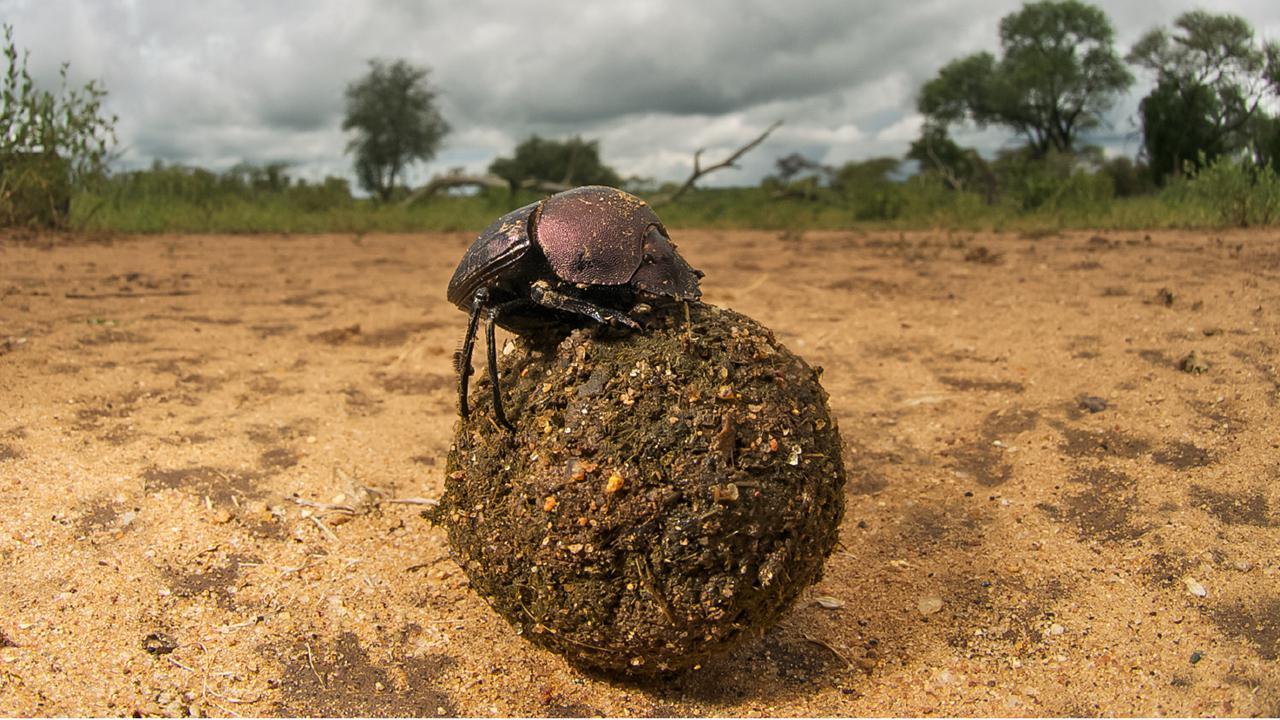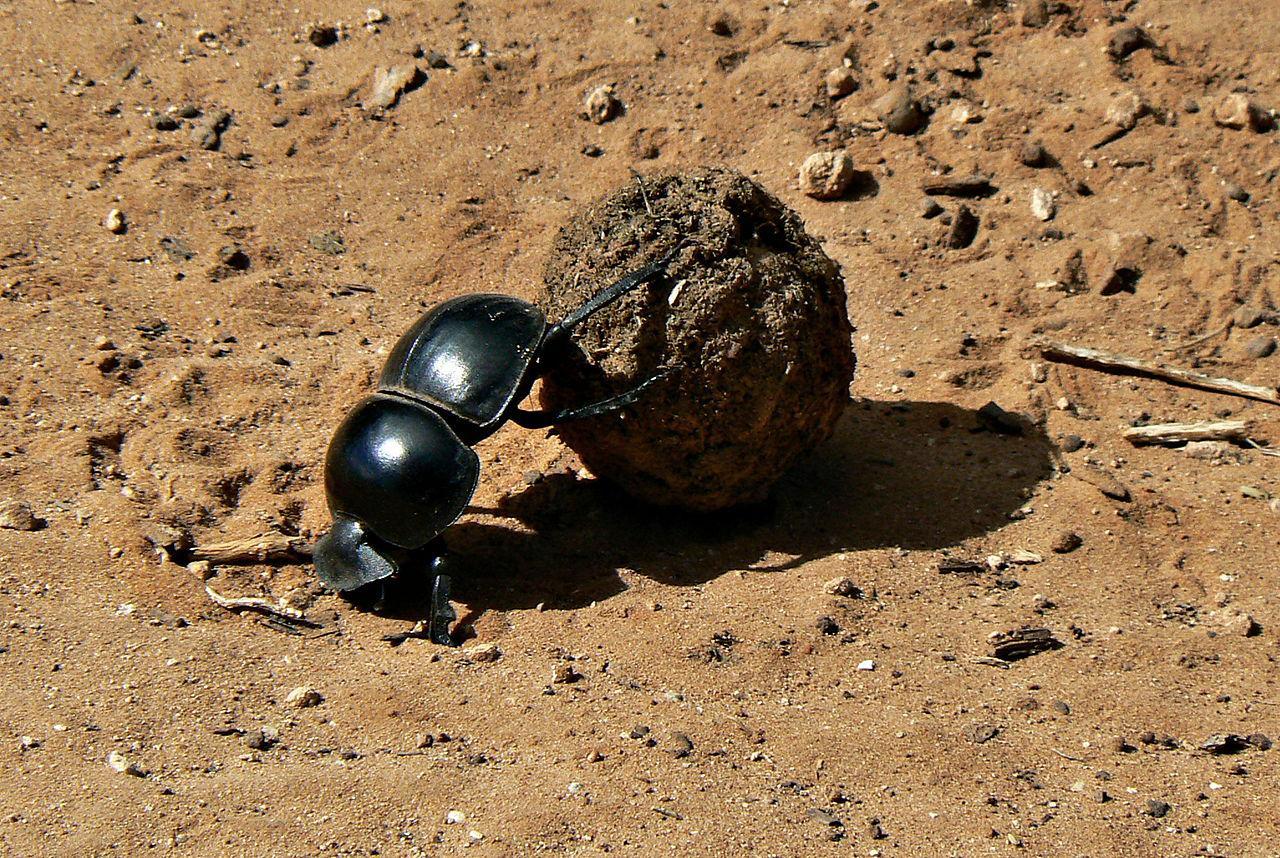The first image is the image on the left, the second image is the image on the right. Considering the images on both sides, is "There is one beetle that is not touching a ball of dung." valid? Answer yes or no. No. 